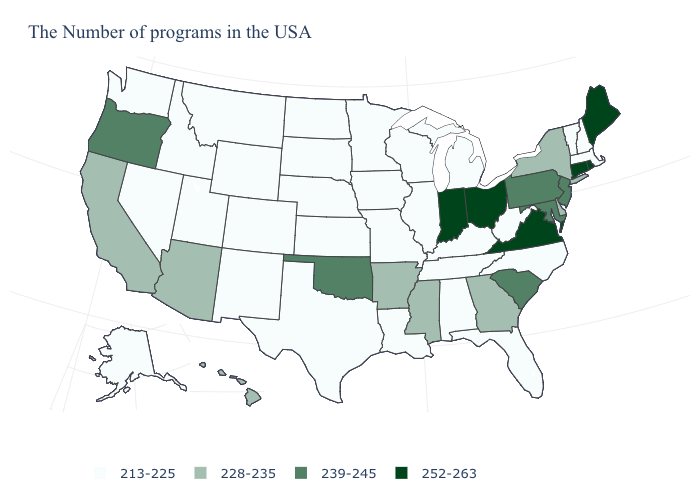What is the value of Wyoming?
Quick response, please. 213-225. How many symbols are there in the legend?
Be succinct. 4. What is the value of Wyoming?
Be succinct. 213-225. Among the states that border Wisconsin , which have the highest value?
Quick response, please. Michigan, Illinois, Minnesota, Iowa. Name the states that have a value in the range 213-225?
Answer briefly. Massachusetts, New Hampshire, Vermont, North Carolina, West Virginia, Florida, Michigan, Kentucky, Alabama, Tennessee, Wisconsin, Illinois, Louisiana, Missouri, Minnesota, Iowa, Kansas, Nebraska, Texas, South Dakota, North Dakota, Wyoming, Colorado, New Mexico, Utah, Montana, Idaho, Nevada, Washington, Alaska. Does Missouri have a lower value than Arkansas?
Concise answer only. Yes. Which states have the highest value in the USA?
Answer briefly. Maine, Rhode Island, Connecticut, Virginia, Ohio, Indiana. Name the states that have a value in the range 228-235?
Be succinct. New York, Delaware, Georgia, Mississippi, Arkansas, Arizona, California, Hawaii. What is the highest value in the USA?
Answer briefly. 252-263. Name the states that have a value in the range 252-263?
Give a very brief answer. Maine, Rhode Island, Connecticut, Virginia, Ohio, Indiana. What is the highest value in states that border Idaho?
Keep it brief. 239-245. Which states have the highest value in the USA?
Quick response, please. Maine, Rhode Island, Connecticut, Virginia, Ohio, Indiana. Name the states that have a value in the range 239-245?
Quick response, please. New Jersey, Maryland, Pennsylvania, South Carolina, Oklahoma, Oregon. What is the value of Florida?
Write a very short answer. 213-225. 